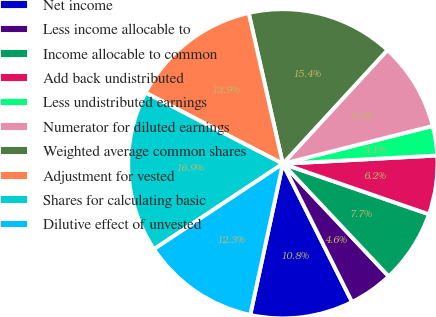Convert chart. <chart><loc_0><loc_0><loc_500><loc_500><pie_chart><fcel>Net income<fcel>Less income allocable to<fcel>Income allocable to common<fcel>Add back undistributed<fcel>Less undistributed earnings<fcel>Numerator for diluted earnings<fcel>Weighted average common shares<fcel>Adjustment for vested<fcel>Shares for calculating basic<fcel>Dilutive effect of unvested<nl><fcel>10.77%<fcel>4.62%<fcel>7.69%<fcel>6.15%<fcel>3.08%<fcel>9.23%<fcel>15.38%<fcel>13.85%<fcel>16.92%<fcel>12.31%<nl></chart> 